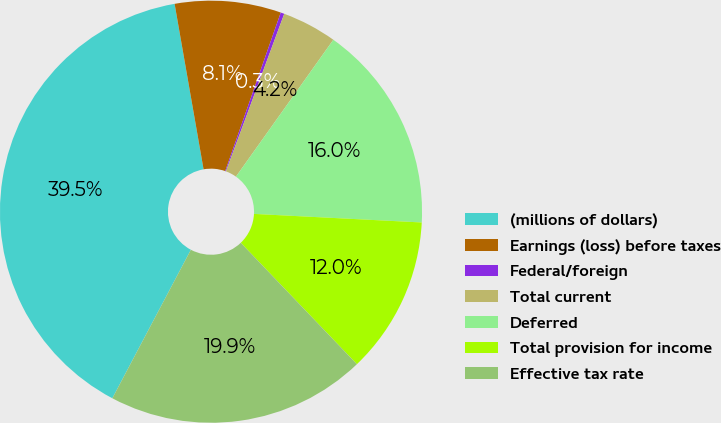Convert chart. <chart><loc_0><loc_0><loc_500><loc_500><pie_chart><fcel>(millions of dollars)<fcel>Earnings (loss) before taxes<fcel>Federal/foreign<fcel>Total current<fcel>Deferred<fcel>Total provision for income<fcel>Effective tax rate<nl><fcel>39.5%<fcel>8.12%<fcel>0.28%<fcel>4.2%<fcel>15.97%<fcel>12.04%<fcel>19.89%<nl></chart> 